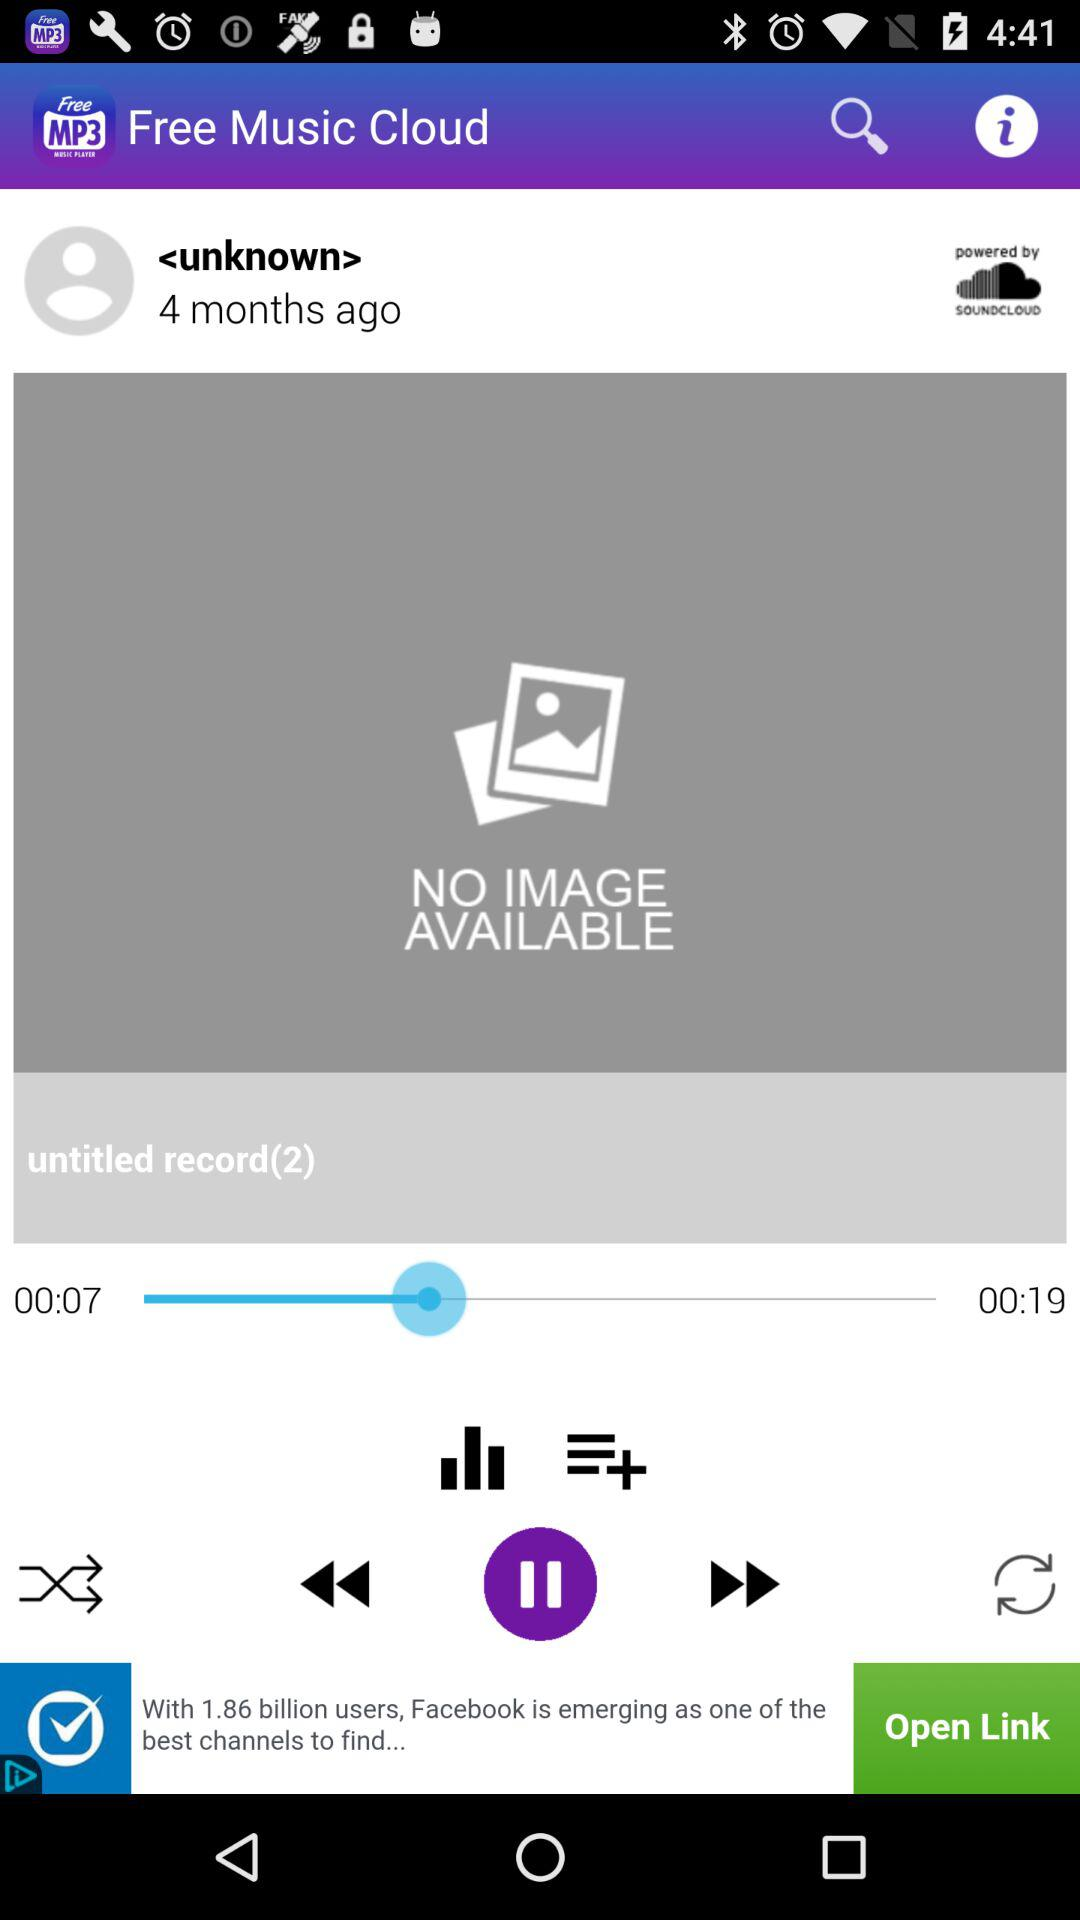How many seconds longer is the second track than the first track? Based on the time indicators shown in the image, which depict the first track having a duration of 7 seconds (00:07) and the second track being 19 seconds long (00:19), the second track is 12 seconds longer than the first. 